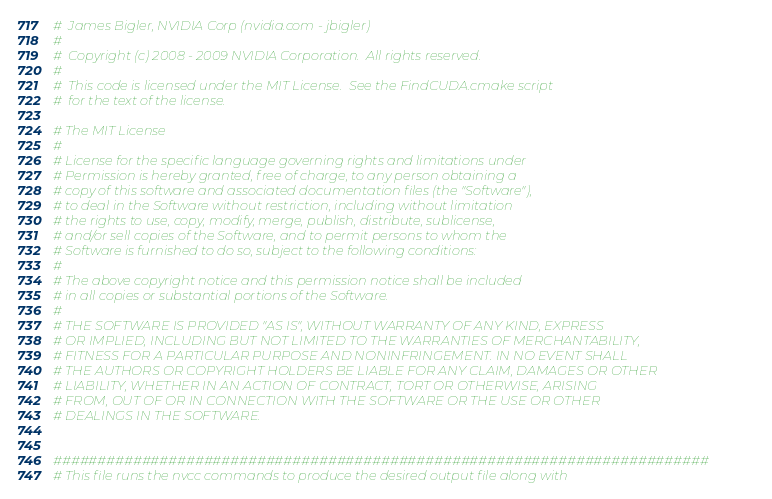<code> <loc_0><loc_0><loc_500><loc_500><_CMake_>#  James Bigler, NVIDIA Corp (nvidia.com - jbigler)
#
#  Copyright (c) 2008 - 2009 NVIDIA Corporation.  All rights reserved.
#
#  This code is licensed under the MIT License.  See the FindCUDA.cmake script
#  for the text of the license.

# The MIT License
#
# License for the specific language governing rights and limitations under
# Permission is hereby granted, free of charge, to any person obtaining a
# copy of this software and associated documentation files (the "Software"),
# to deal in the Software without restriction, including without limitation
# the rights to use, copy, modify, merge, publish, distribute, sublicense,
# and/or sell copies of the Software, and to permit persons to whom the
# Software is furnished to do so, subject to the following conditions:
#
# The above copyright notice and this permission notice shall be included
# in all copies or substantial portions of the Software.
#
# THE SOFTWARE IS PROVIDED "AS IS", WITHOUT WARRANTY OF ANY KIND, EXPRESS
# OR IMPLIED, INCLUDING BUT NOT LIMITED TO THE WARRANTIES OF MERCHANTABILITY,
# FITNESS FOR A PARTICULAR PURPOSE AND NONINFRINGEMENT. IN NO EVENT SHALL
# THE AUTHORS OR COPYRIGHT HOLDERS BE LIABLE FOR ANY CLAIM, DAMAGES OR OTHER
# LIABILITY, WHETHER IN AN ACTION OF CONTRACT, TORT OR OTHERWISE, ARISING
# FROM, OUT OF OR IN CONNECTION WITH THE SOFTWARE OR THE USE OR OTHER
# DEALINGS IN THE SOFTWARE.


##########################################################################
# This file runs the nvcc commands to produce the desired output file along with</code> 